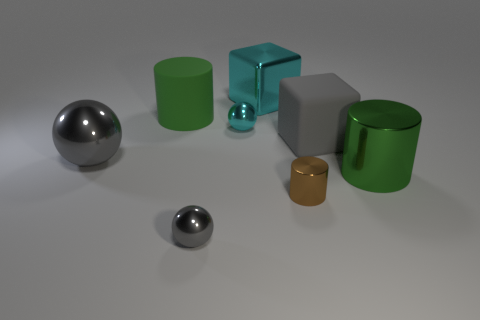Subtract all big cylinders. How many cylinders are left? 1 Subtract all purple spheres. How many green cylinders are left? 2 Add 1 cyan spheres. How many objects exist? 9 Subtract all balls. How many objects are left? 5 Subtract 2 green cylinders. How many objects are left? 6 Subtract all green balls. Subtract all cyan cylinders. How many balls are left? 3 Subtract all big gray things. Subtract all green matte objects. How many objects are left? 5 Add 7 brown cylinders. How many brown cylinders are left? 8 Add 5 tiny red cylinders. How many tiny red cylinders exist? 5 